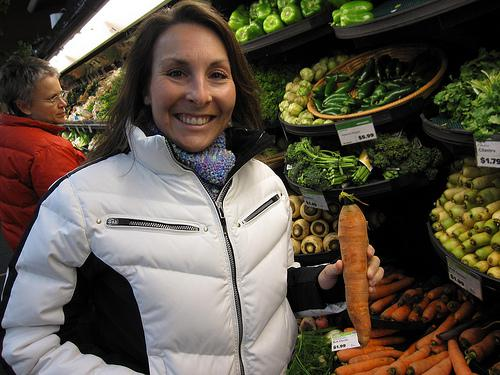Question: where was the picture taken?
Choices:
A. Downtown.
B. Supermarket.
C. Shopping Center.
D. Hardware Store.
Answer with the letter. Answer: B Question: why is the woman wearing a jacket?
Choices:
A. Cold.
B. Breezy.
C. Raining.
D. It matches her outfit.
Answer with the letter. Answer: A Question: who is smiling?
Choices:
A. Man.
B. Girl.
C. Boy.
D. Woman.
Answer with the letter. Answer: D Question: what section in the store are the woman in?
Choices:
A. Meat.
B. Canned Goods.
C. Produce.
D. Bakery.
Answer with the letter. Answer: C Question: what is does the woman in the background have on her face?
Choices:
A. Birthmark.
B. Make-up.
C. Glasses.
D. Smudge.
Answer with the letter. Answer: C 